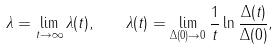Convert formula to latex. <formula><loc_0><loc_0><loc_500><loc_500>\lambda = \lim _ { t \to \infty } \lambda ( t ) , \quad \lambda ( t ) = \lim _ { \Delta ( 0 ) \to 0 } \frac { 1 } { t } \ln \frac { \Delta ( t ) } { \Delta ( 0 ) } ,</formula> 